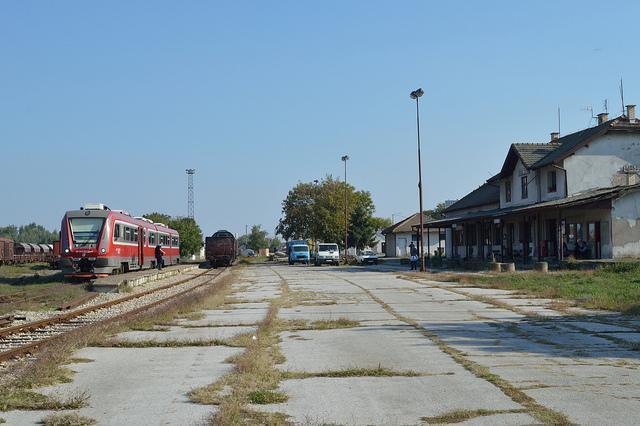How many light posts are in the picture?
Give a very brief answer. 2. How many tracks are there?
Give a very brief answer. 1. How many giraffe are laying on the ground?
Give a very brief answer. 0. 